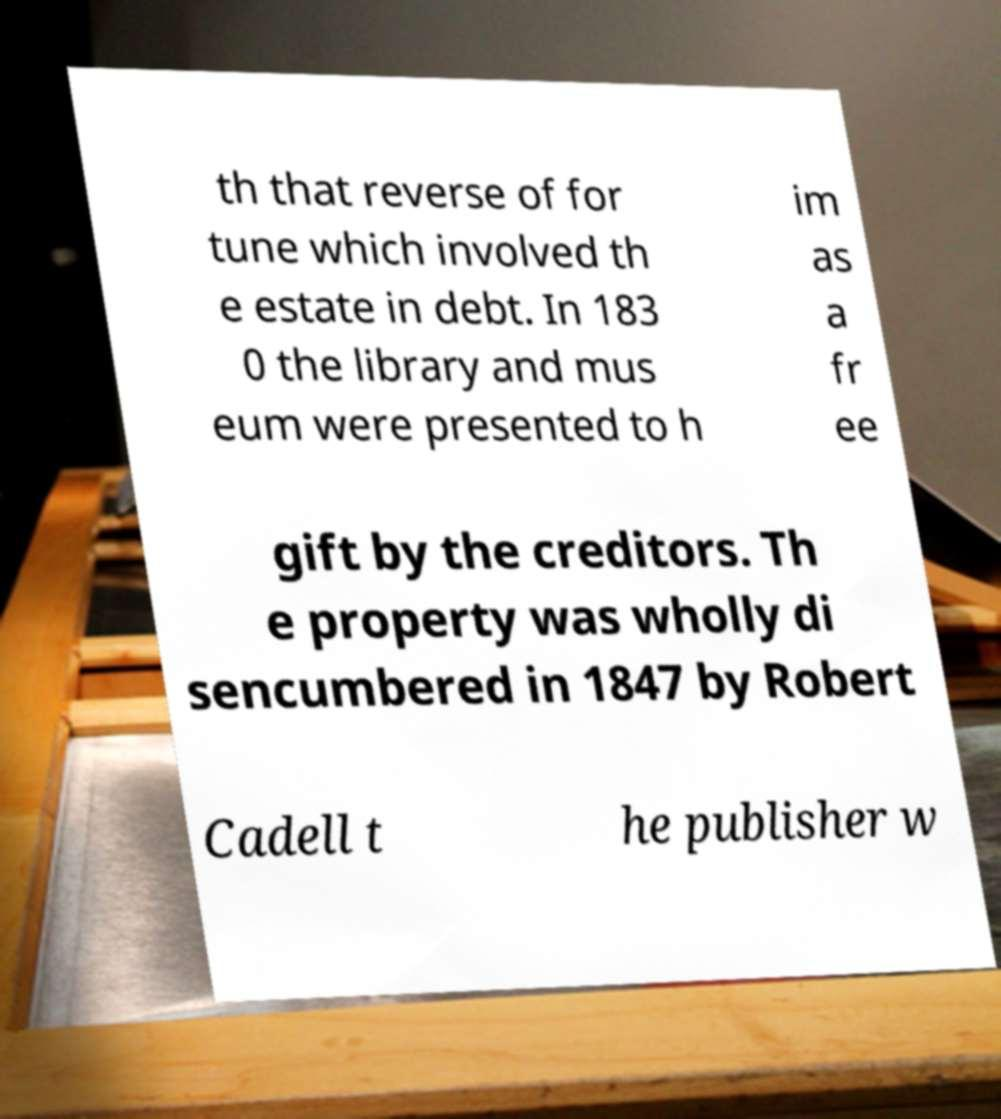Could you assist in decoding the text presented in this image and type it out clearly? th that reverse of for tune which involved th e estate in debt. In 183 0 the library and mus eum were presented to h im as a fr ee gift by the creditors. Th e property was wholly di sencumbered in 1847 by Robert Cadell t he publisher w 